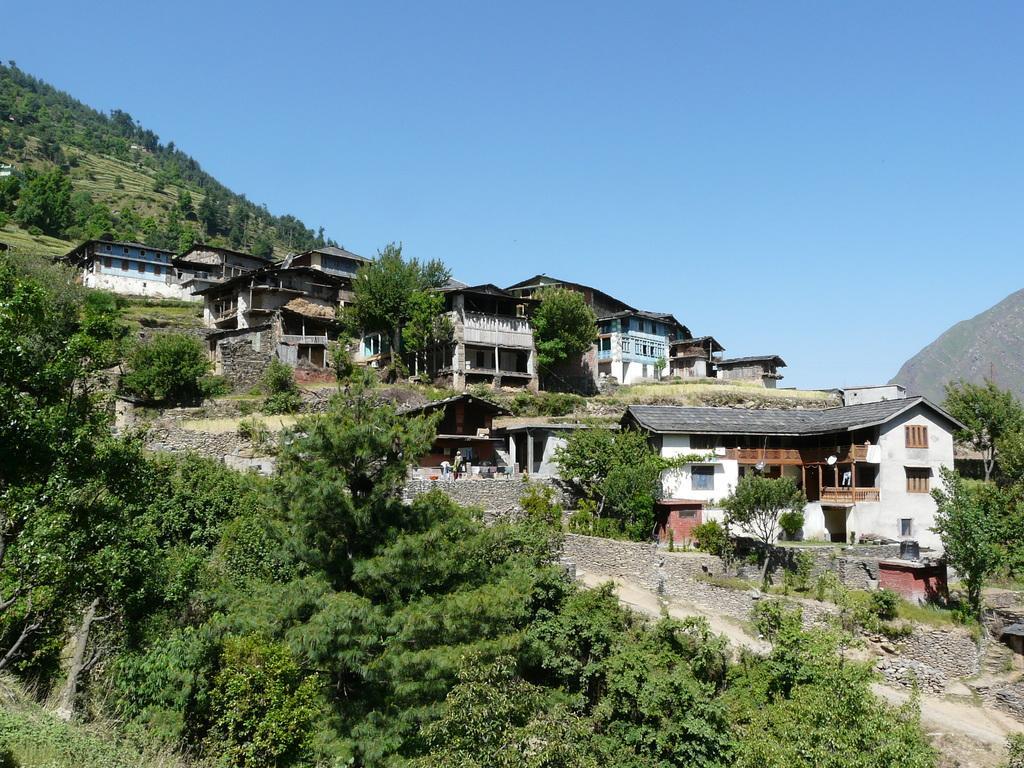Please provide a concise description of this image. In the background we can see the sky, hills with the thicket. This picture is mainly highlighted with the houses. We can see the trees and plants. On the right side of the picture we can see a black tank. 